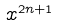Convert formula to latex. <formula><loc_0><loc_0><loc_500><loc_500>x ^ { 2 n + 1 }</formula> 